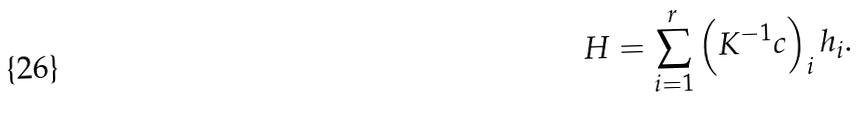<formula> <loc_0><loc_0><loc_500><loc_500>H = \sum ^ { r } _ { i = 1 } \left ( K ^ { - 1 } c \right ) _ { i } h _ { i } .</formula> 